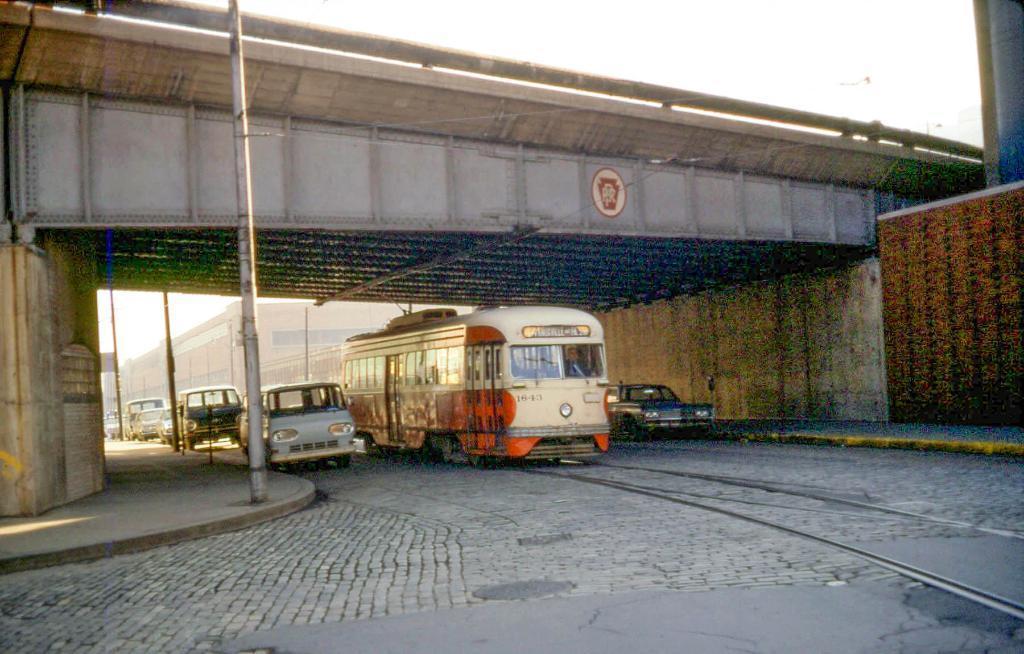Please provide a concise description of this image. In this image there are vehicles on the road, a train on the railway track, there is a bridge, a building, and in the background there is sky. 